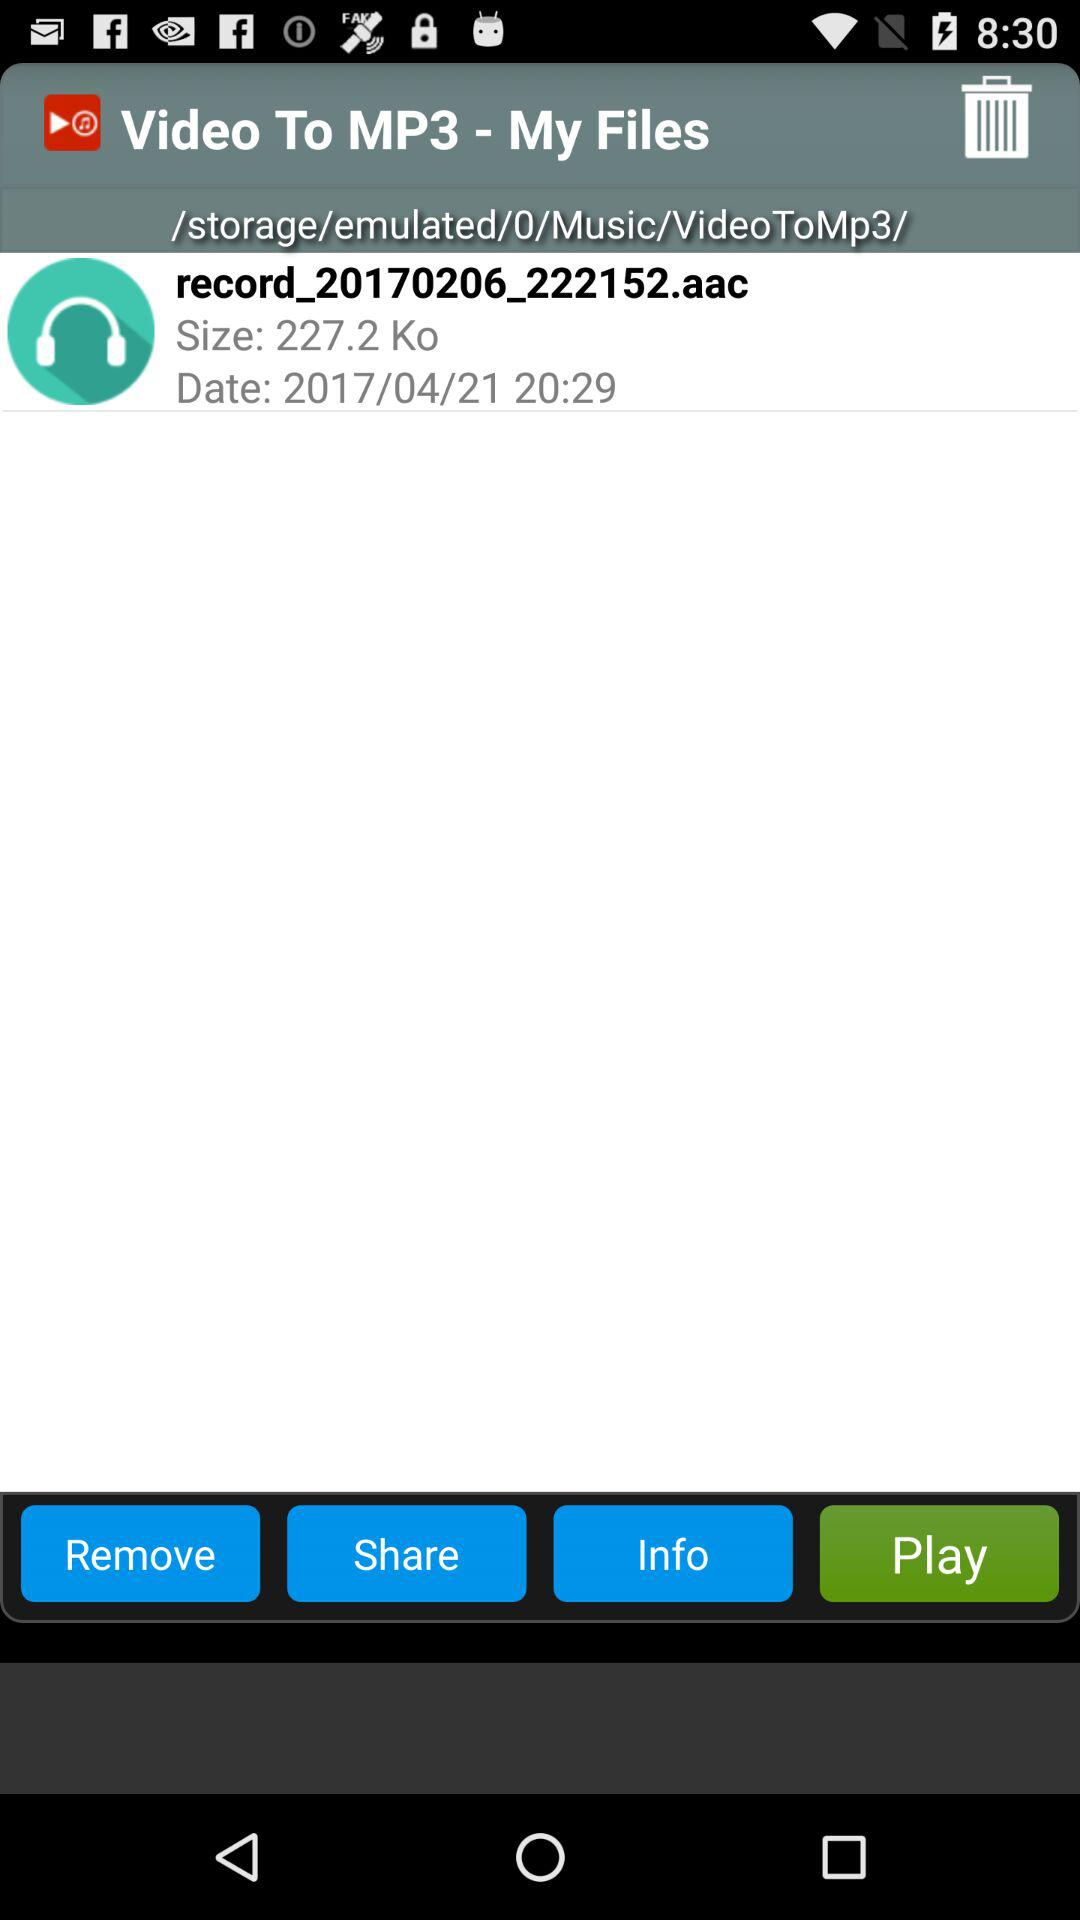What is the shown date? The shown date is April 21, 2017. 